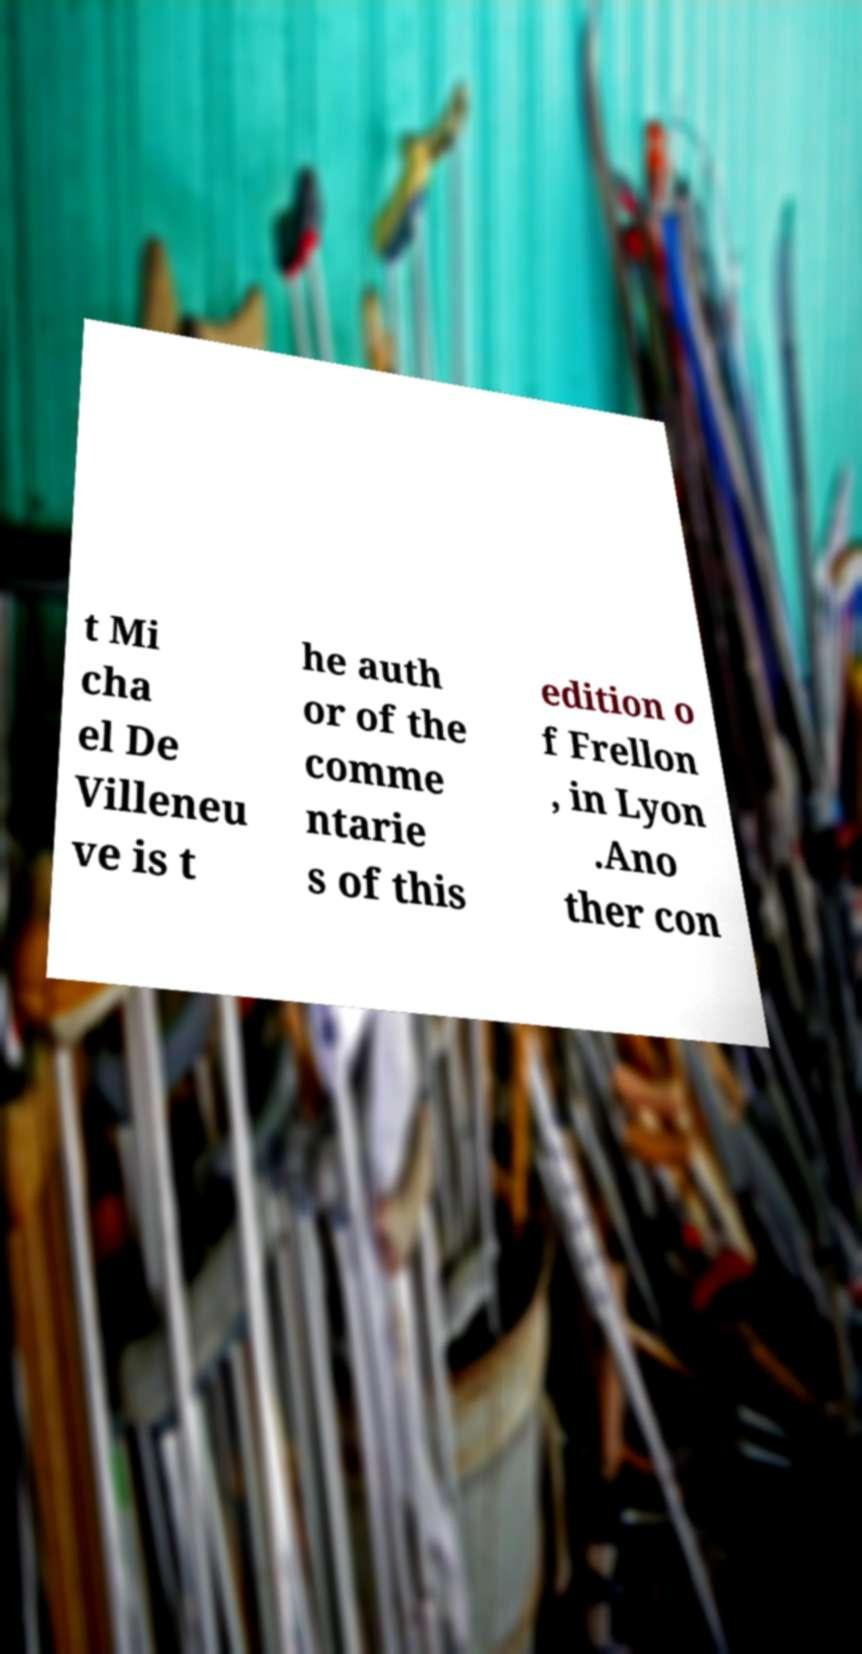Can you read and provide the text displayed in the image?This photo seems to have some interesting text. Can you extract and type it out for me? t Mi cha el De Villeneu ve is t he auth or of the comme ntarie s of this edition o f Frellon , in Lyon .Ano ther con 